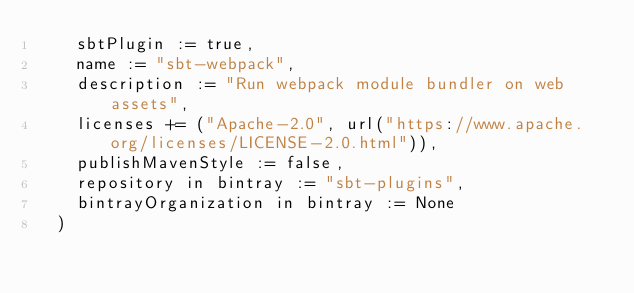Convert code to text. <code><loc_0><loc_0><loc_500><loc_500><_Scala_>    sbtPlugin := true,
    name := "sbt-webpack",
    description := "Run webpack module bundler on web assets",
    licenses += ("Apache-2.0", url("https://www.apache.org/licenses/LICENSE-2.0.html")),
    publishMavenStyle := false,
    repository in bintray := "sbt-plugins",
    bintrayOrganization in bintray := None
  )</code> 